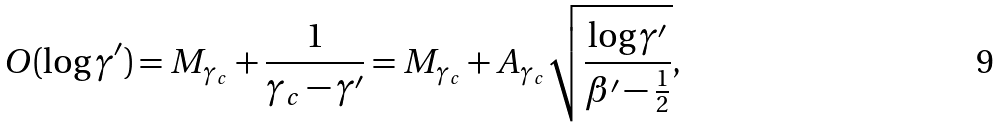Convert formula to latex. <formula><loc_0><loc_0><loc_500><loc_500>O ( \log \gamma ^ { \prime } ) = M _ { \gamma _ { c } } + \frac { 1 } { \gamma _ { c } - \gamma ^ { \prime } } = M _ { \gamma _ { c } } + A _ { \gamma _ { c } } \sqrt { \frac { \log \gamma ^ { \prime } } { \beta ^ { \prime } - \frac { 1 } { 2 } } } ,</formula> 